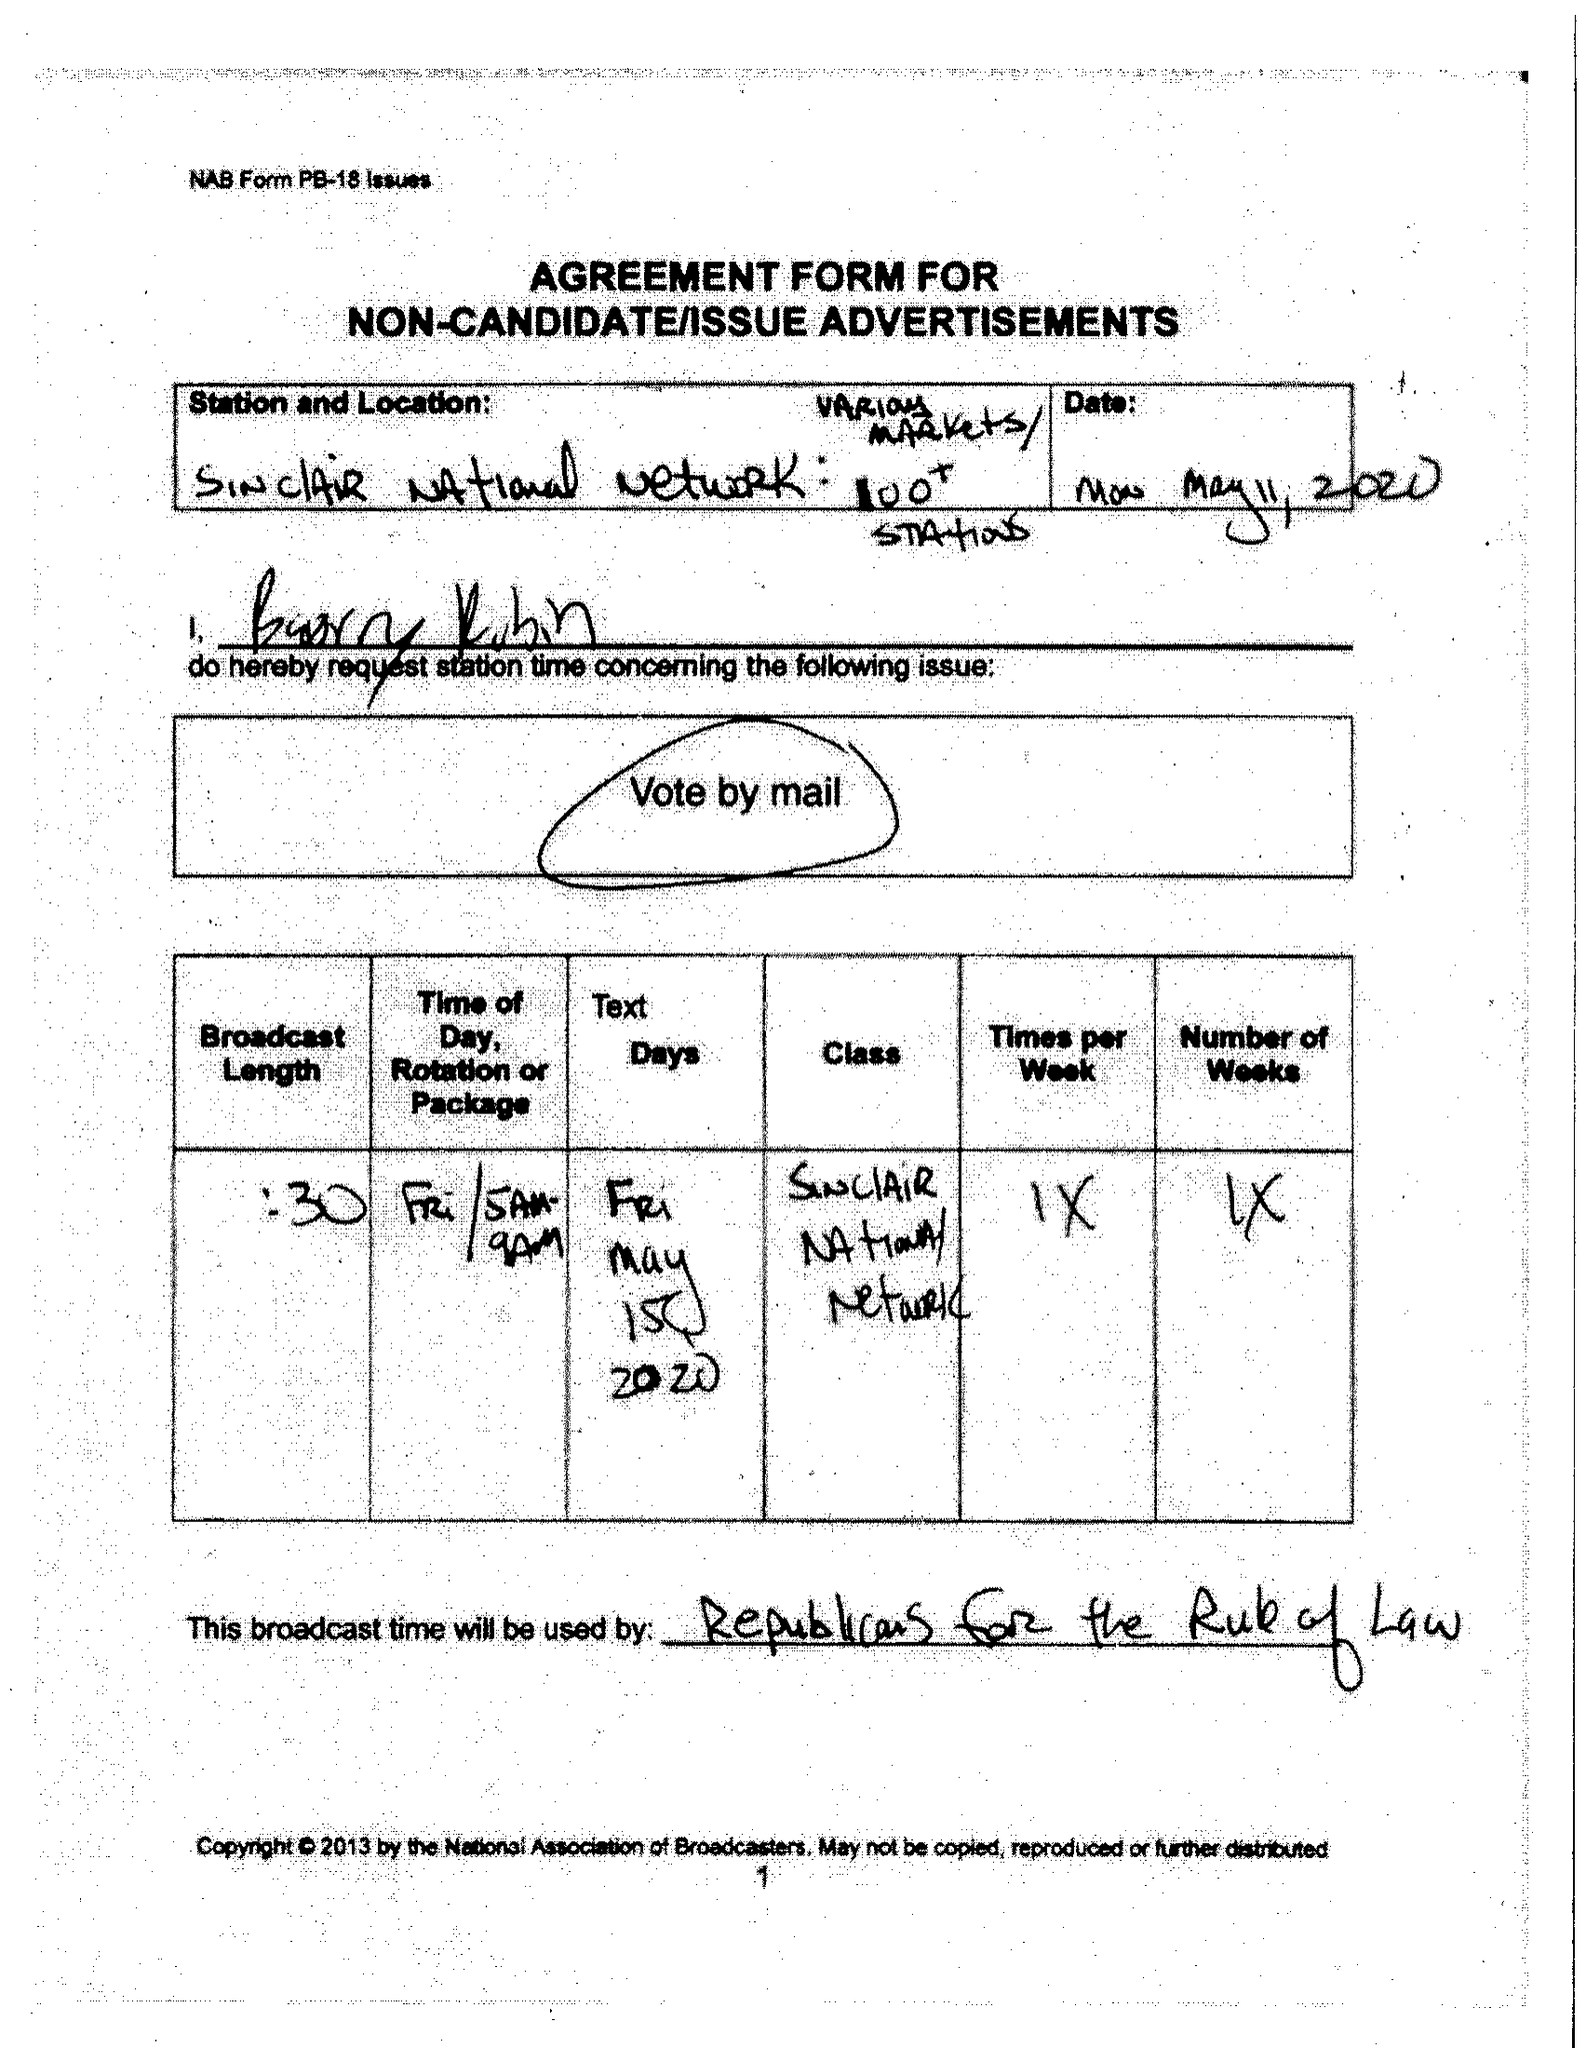What is the value for the flight_to?
Answer the question using a single word or phrase. None 